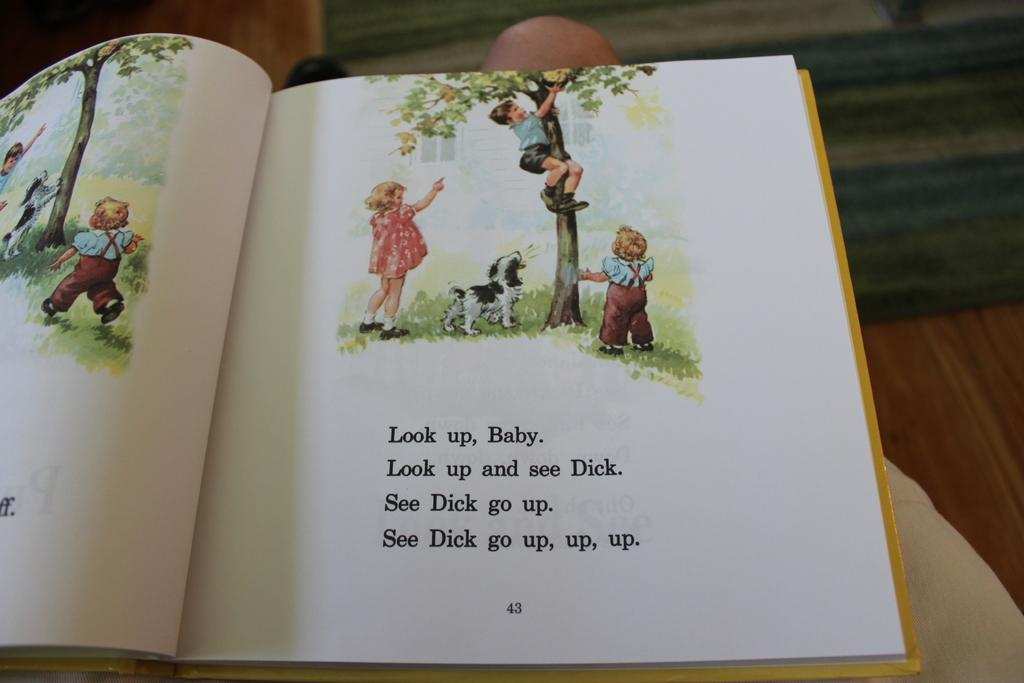<image>
Relay a brief, clear account of the picture shown. An illustrated page in a book depicts the narrator telling the Baby to "Look up." 